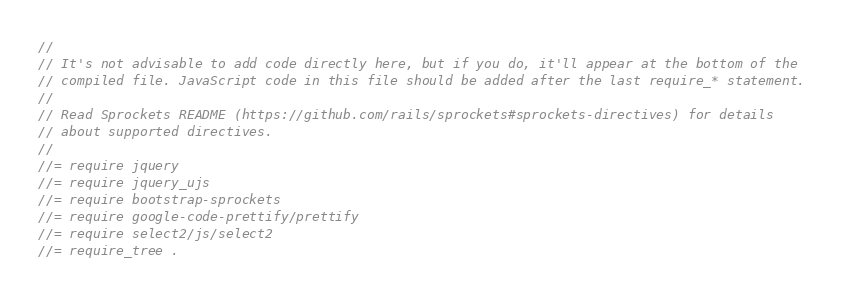<code> <loc_0><loc_0><loc_500><loc_500><_JavaScript_>//
// It's not advisable to add code directly here, but if you do, it'll appear at the bottom of the
// compiled file. JavaScript code in this file should be added after the last require_* statement.
//
// Read Sprockets README (https://github.com/rails/sprockets#sprockets-directives) for details
// about supported directives.
//
//= require jquery
//= require jquery_ujs
//= require bootstrap-sprockets
//= require google-code-prettify/prettify
//= require select2/js/select2
//= require_tree .
</code> 